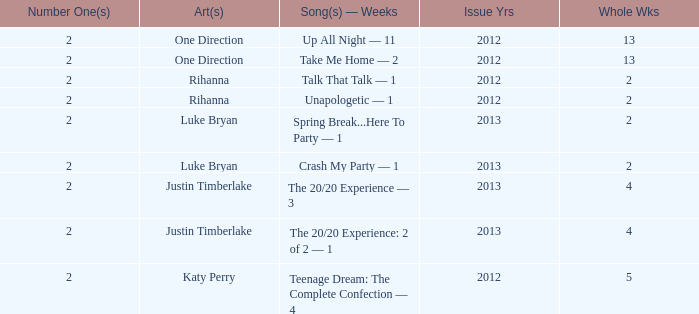Could you parse the entire table? {'header': ['Number One(s)', 'Art(s)', 'Song(s) — Weeks', 'Issue Yrs', 'Whole Wks'], 'rows': [['2', 'One Direction', 'Up All Night — 11', '2012', '13'], ['2', 'One Direction', 'Take Me Home — 2', '2012', '13'], ['2', 'Rihanna', 'Talk That Talk — 1', '2012', '2'], ['2', 'Rihanna', 'Unapologetic — 1', '2012', '2'], ['2', 'Luke Bryan', 'Spring Break...Here To Party — 1', '2013', '2'], ['2', 'Luke Bryan', 'Crash My Party — 1', '2013', '2'], ['2', 'Justin Timberlake', 'The 20/20 Experience — 3', '2013', '4'], ['2', 'Justin Timberlake', 'The 20/20 Experience: 2 of 2 — 1', '2013', '4'], ['2', 'Katy Perry', 'Teenage Dream: The Complete Confection — 4', '2012', '5']]} What is the title of every song, and how many weeks was each song at #1 for One Direction? Up All Night — 11, Take Me Home — 2. 